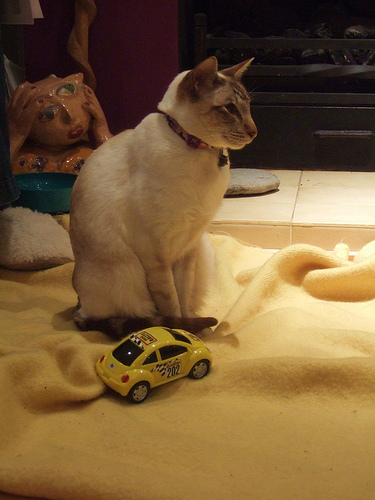Can you describe the broader setting in which the cat is found? The cat is seated indoors, likely in a home environment, evidenced by the domestic items in the background like the soft blanket, a plush toy, and a decorative object that resembles a cat. It seems to be nighttime or in a low-light setting as indicated by the warm artificial lighting and shadows cast in the area. 